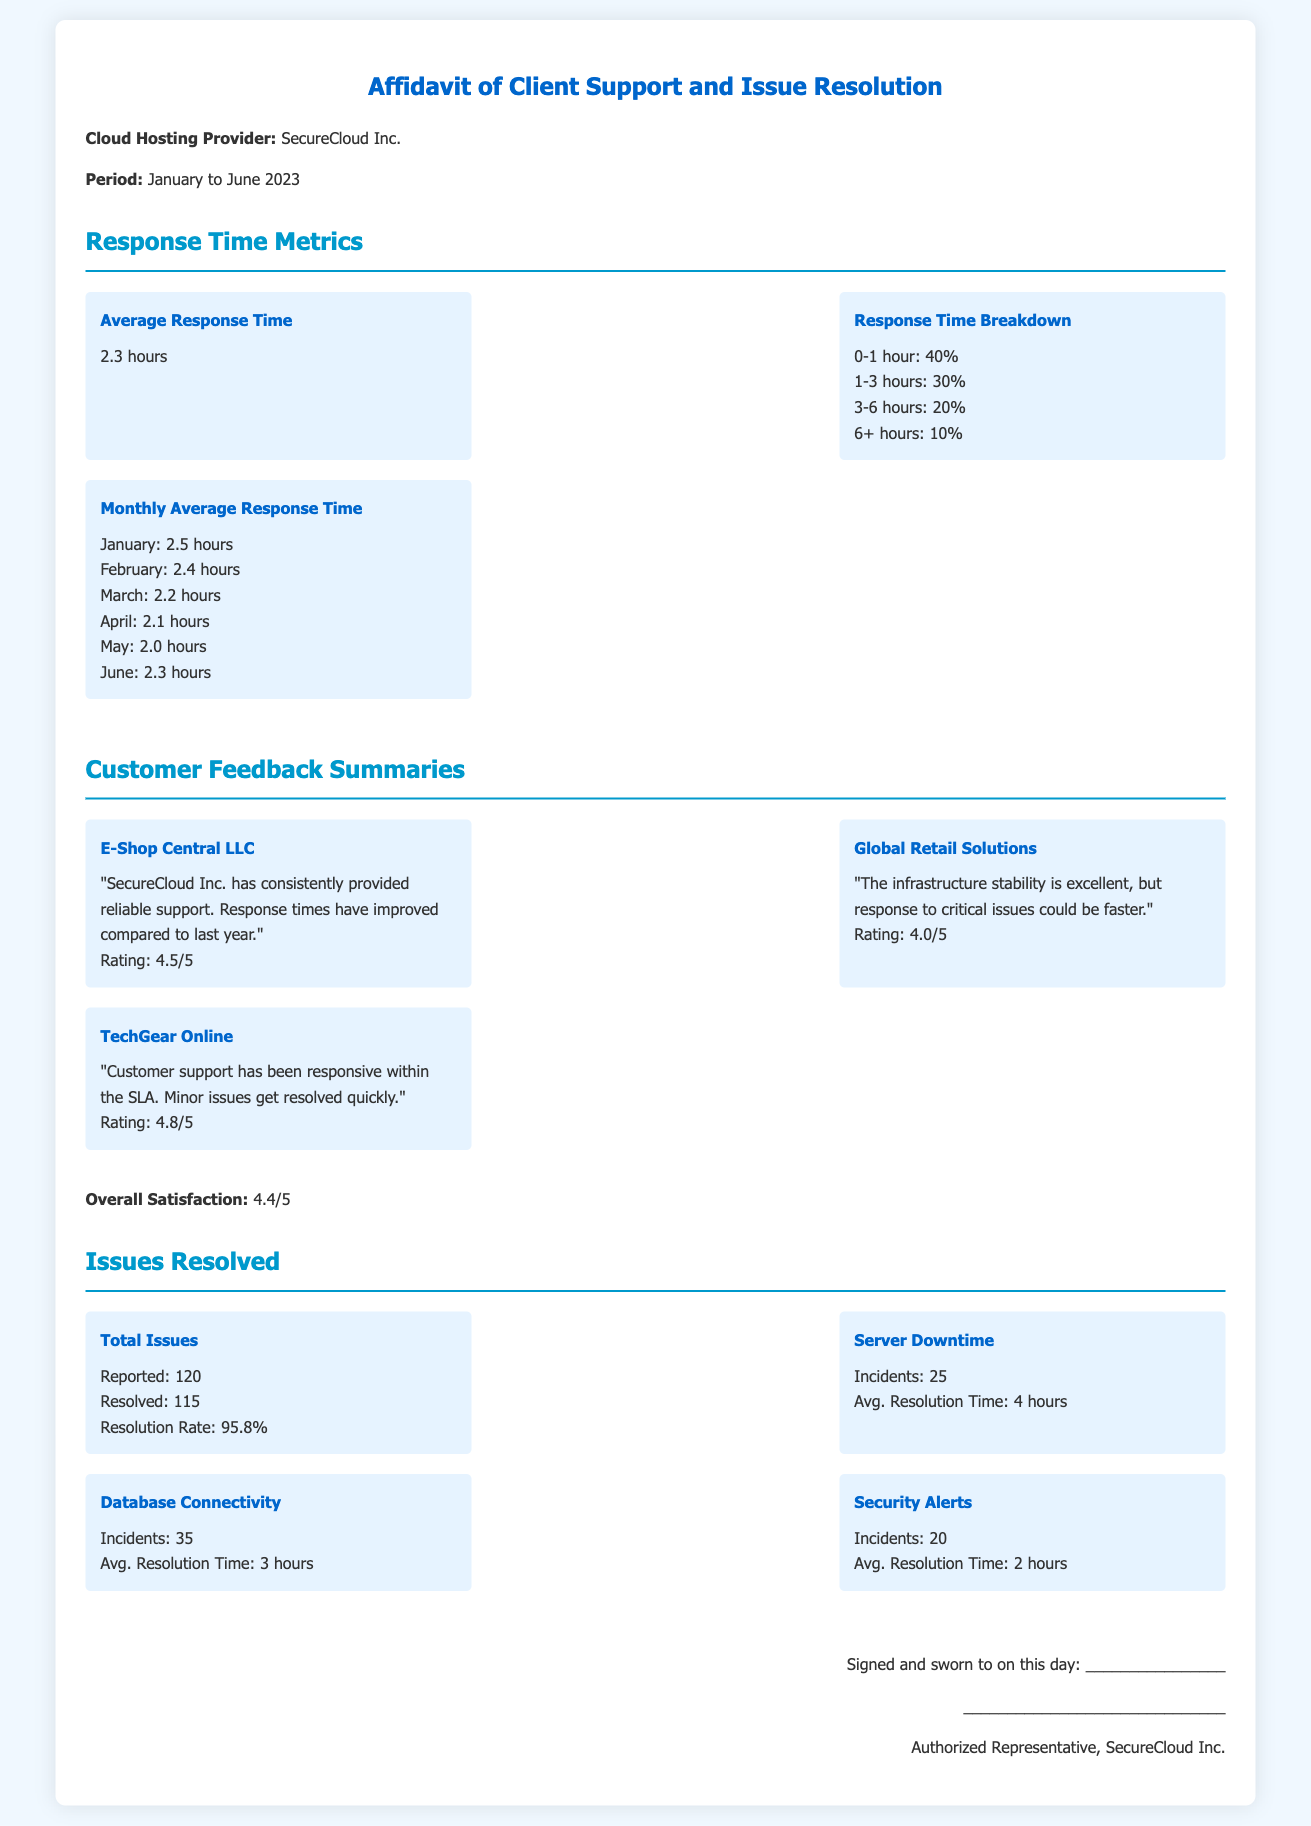What is the average response time? The average response time is mentioned as a specific metric in the document.
Answer: 2.3 hours What was the response time for March? The response time for March is provided in the monthly average section of the document.
Answer: 2.2 hours How many total issues were reported? The total number of reported issues is specified in the "Issues Resolved" section of the document.
Answer: 120 What is the overall customer satisfaction rating? The overall customer satisfaction rating is summarized at the end of the feedback section.
Answer: 4.4/5 What percentage of issues were resolved? The resolution rate is included in the "Issues Resolved" section and gives the percentage of resolved issues.
Answer: 95.8% Which customer provided the highest rating? The customer feedback section lists the ratings provided by different clients; the one with the highest rating can be found there.
Answer: TechGear Online What incident had the lowest average resolution time? The average resolution time for different incidents is provided, allowing identification of the one with the lowest time.
Answer: Security Alerts Which month had the best average response time, and what was it? By examining the monthly average response time data, the month with the best performance can be identified.
Answer: April: 2.1 hours 